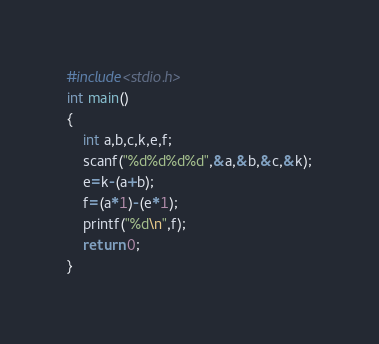<code> <loc_0><loc_0><loc_500><loc_500><_C++_>#include<stdio.h>
int main()
{
    int a,b,c,k,e,f;
    scanf("%d%d%d%d",&a,&b,&c,&k);
    e=k-(a+b);
    f=(a*1)-(e*1);
    printf("%d\n",f);
    return 0;
}</code> 